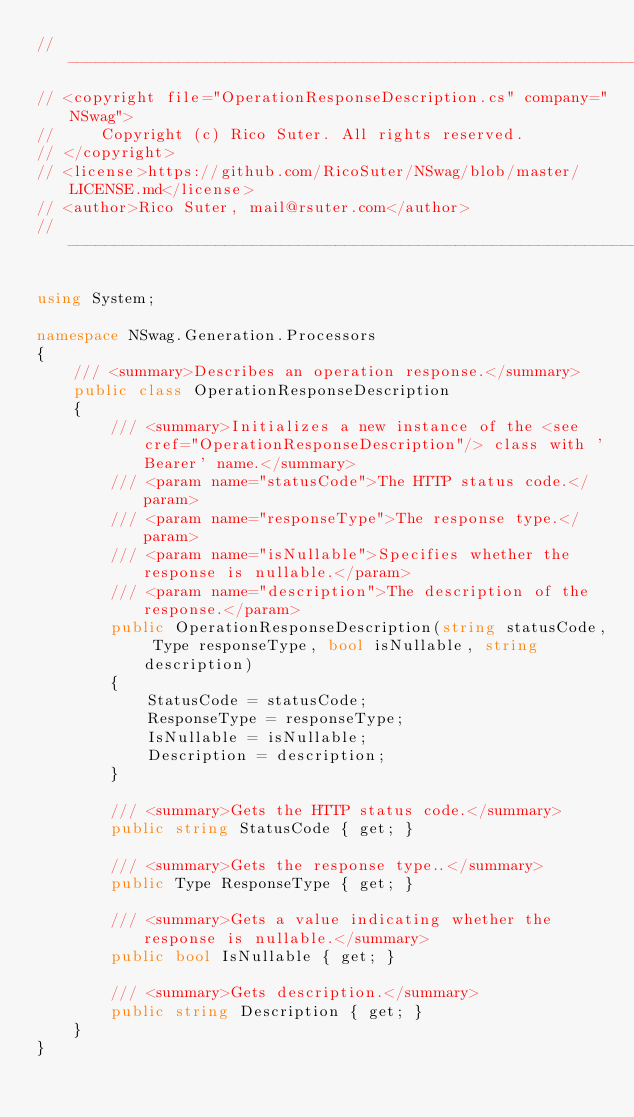Convert code to text. <code><loc_0><loc_0><loc_500><loc_500><_C#_>//-----------------------------------------------------------------------
// <copyright file="OperationResponseDescription.cs" company="NSwag">
//     Copyright (c) Rico Suter. All rights reserved.
// </copyright>
// <license>https://github.com/RicoSuter/NSwag/blob/master/LICENSE.md</license>
// <author>Rico Suter, mail@rsuter.com</author>
//-----------------------------------------------------------------------

using System;

namespace NSwag.Generation.Processors
{
    /// <summary>Describes an operation response.</summary>
    public class OperationResponseDescription
    {
        /// <summary>Initializes a new instance of the <see cref="OperationResponseDescription"/> class with 'Bearer' name.</summary>
        /// <param name="statusCode">The HTTP status code.</param>
        /// <param name="responseType">The response type.</param>
        /// <param name="isNullable">Specifies whether the response is nullable.</param>
        /// <param name="description">The description of the response.</param>
        public OperationResponseDescription(string statusCode, Type responseType, bool isNullable, string description)
        {
            StatusCode = statusCode;
            ResponseType = responseType;
            IsNullable = isNullable;
            Description = description;
        }

        /// <summary>Gets the HTTP status code.</summary>
        public string StatusCode { get; }

        /// <summary>Gets the response type..</summary>
        public Type ResponseType { get; }

        /// <summary>Gets a value indicating whether the response is nullable.</summary>
        public bool IsNullable { get; }

        /// <summary>Gets description.</summary>
        public string Description { get; }
    }
}</code> 